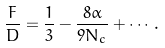Convert formula to latex. <formula><loc_0><loc_0><loc_500><loc_500>\frac { F } { D } = \frac { 1 } { 3 } - \frac { 8 \alpha } { 9 N _ { c } } + \cdots .</formula> 